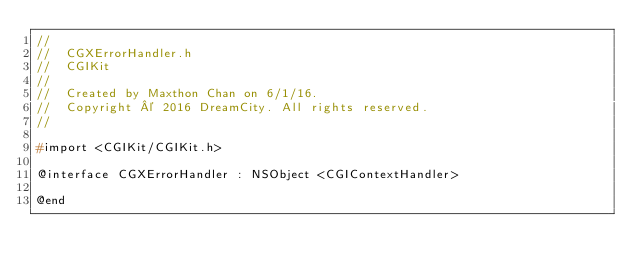Convert code to text. <code><loc_0><loc_0><loc_500><loc_500><_C_>//
//  CGXErrorHandler.h
//  CGIKit
//
//  Created by Maxthon Chan on 6/1/16.
//  Copyright © 2016 DreamCity. All rights reserved.
//

#import <CGIKit/CGIKit.h>

@interface CGXErrorHandler : NSObject <CGIContextHandler>

@end
</code> 